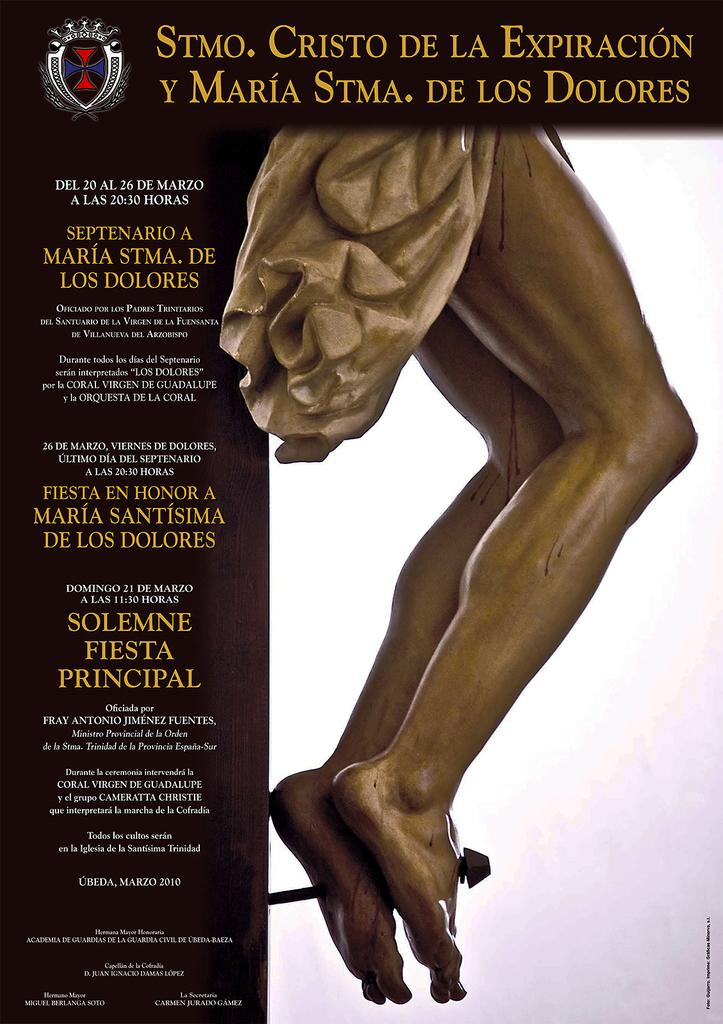What is the main subject of the image? The main subject of the image is a statue. Is there any additional information provided with the image? Yes, there is text associated with the image. How many beds are visible in the image? There are no beds present in the image; it features a statue and text. What type of books can be seen on the statue in the image? There are no books visible in the image, as it only features a statue and text. 